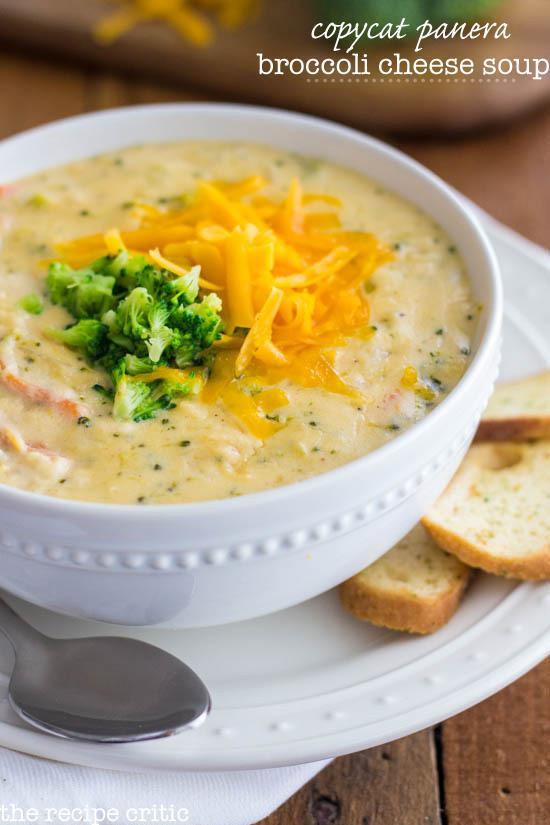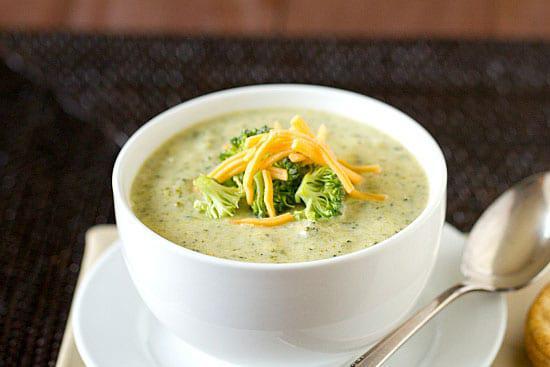The first image is the image on the left, the second image is the image on the right. Examine the images to the left and right. Is the description "There is a white plate beneath the soup in the image on the left." accurate? Answer yes or no. Yes. 